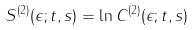Convert formula to latex. <formula><loc_0><loc_0><loc_500><loc_500>S ^ { ( 2 ) } ( \epsilon ; t , s ) = \ln C ^ { ( 2 ) } ( \epsilon ; t , s )</formula> 